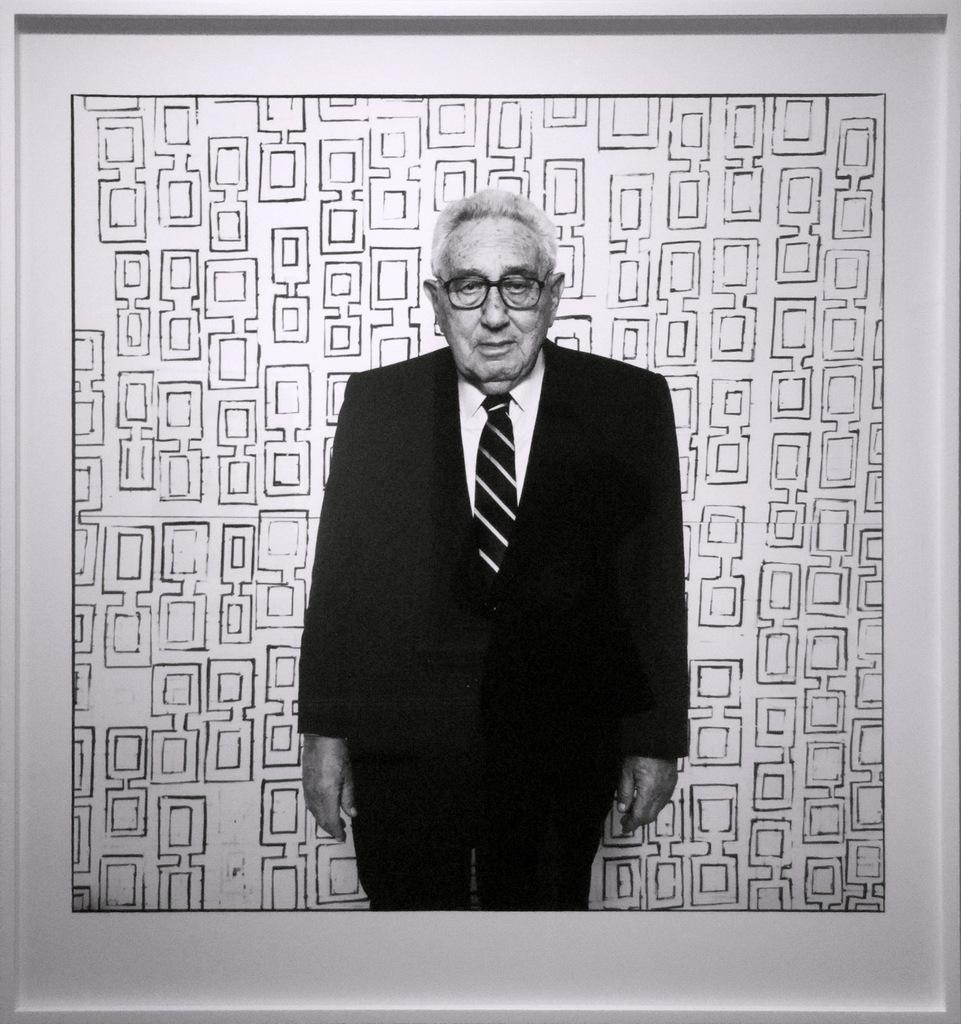What is the color scheme of the image? The image is black and white. Who is the main subject in the image? There is an old man in the image. What is the old man wearing in the image? The old man is wearing a suit. What accessory is the old man wearing in the image? The old man is wearing spectacles. What type of plastic material can be seen in the image? There is no plastic material present in the image. Can you tell me how much credit the old man has in the image? There is no reference to credit or finances in the image. 